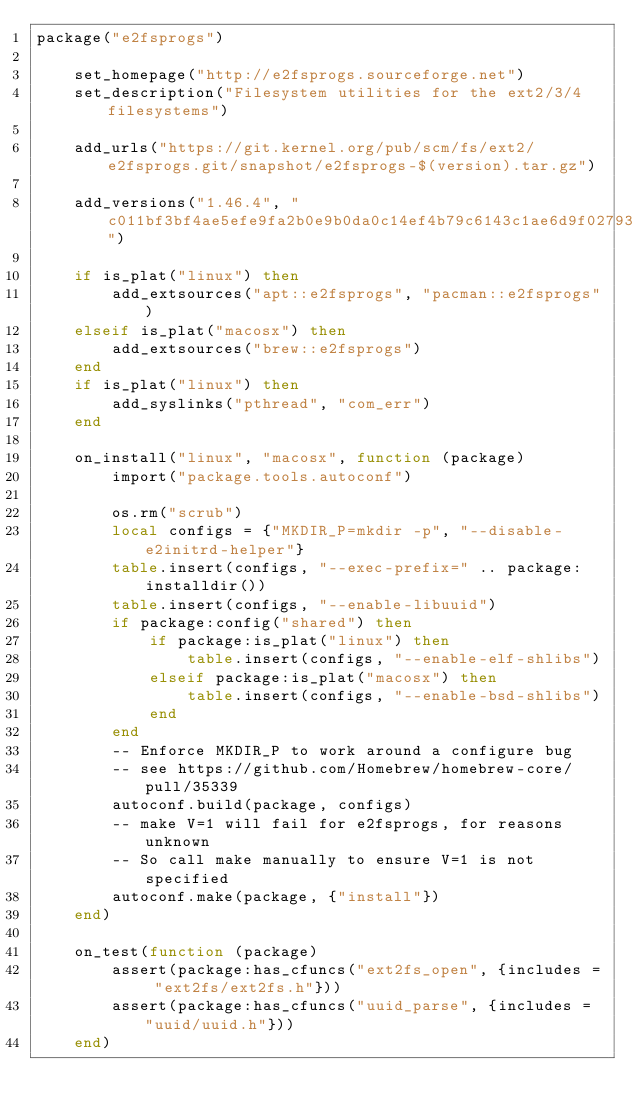<code> <loc_0><loc_0><loc_500><loc_500><_Lua_>package("e2fsprogs")

    set_homepage("http://e2fsprogs.sourceforge.net")
    set_description("Filesystem utilities for the ext2/3/4 filesystems")

    add_urls("https://git.kernel.org/pub/scm/fs/ext2/e2fsprogs.git/snapshot/e2fsprogs-$(version).tar.gz")

    add_versions("1.46.4", "c011bf3bf4ae5efe9fa2b0e9b0da0c14ef4b79c6143c1ae6d9f027931ec7abe1")

    if is_plat("linux") then
        add_extsources("apt::e2fsprogs", "pacman::e2fsprogs")
    elseif is_plat("macosx") then
        add_extsources("brew::e2fsprogs")
    end
    if is_plat("linux") then
        add_syslinks("pthread", "com_err")
    end

    on_install("linux", "macosx", function (package)
        import("package.tools.autoconf")

        os.rm("scrub")
        local configs = {"MKDIR_P=mkdir -p", "--disable-e2initrd-helper"}
        table.insert(configs, "--exec-prefix=" .. package:installdir())
        table.insert(configs, "--enable-libuuid")
        if package:config("shared") then
            if package:is_plat("linux") then
                table.insert(configs, "--enable-elf-shlibs")
            elseif package:is_plat("macosx") then
                table.insert(configs, "--enable-bsd-shlibs")
            end
        end
        -- Enforce MKDIR_P to work around a configure bug
        -- see https://github.com/Homebrew/homebrew-core/pull/35339
        autoconf.build(package, configs)
        -- make V=1 will fail for e2fsprogs, for reasons unknown
        -- So call make manually to ensure V=1 is not specified
        autoconf.make(package, {"install"})
    end)

    on_test(function (package)
        assert(package:has_cfuncs("ext2fs_open", {includes = "ext2fs/ext2fs.h"}))
        assert(package:has_cfuncs("uuid_parse", {includes = "uuid/uuid.h"}))
    end)
</code> 